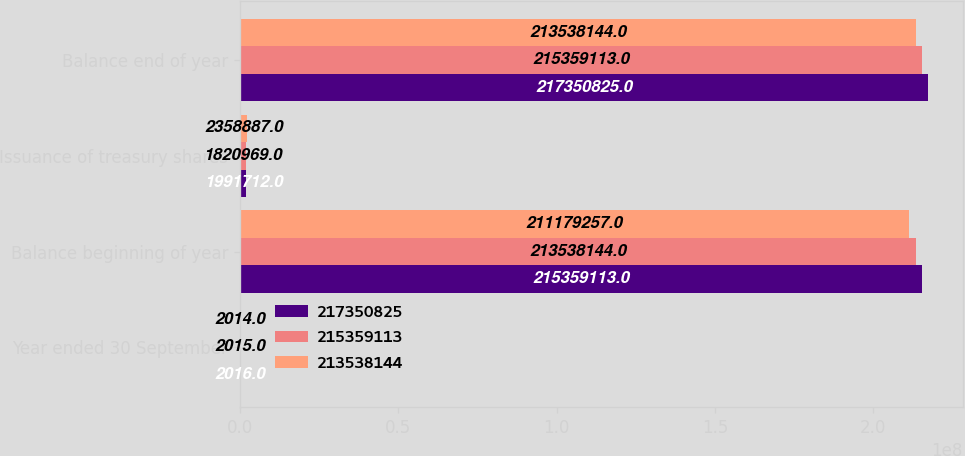Convert chart. <chart><loc_0><loc_0><loc_500><loc_500><stacked_bar_chart><ecel><fcel>Year ended 30 September<fcel>Balance beginning of year<fcel>Issuance of treasury shares<fcel>Balance end of year<nl><fcel>2.17351e+08<fcel>2016<fcel>2.15359e+08<fcel>1.99171e+06<fcel>2.17351e+08<nl><fcel>2.15359e+08<fcel>2015<fcel>2.13538e+08<fcel>1.82097e+06<fcel>2.15359e+08<nl><fcel>2.13538e+08<fcel>2014<fcel>2.11179e+08<fcel>2.35889e+06<fcel>2.13538e+08<nl></chart> 